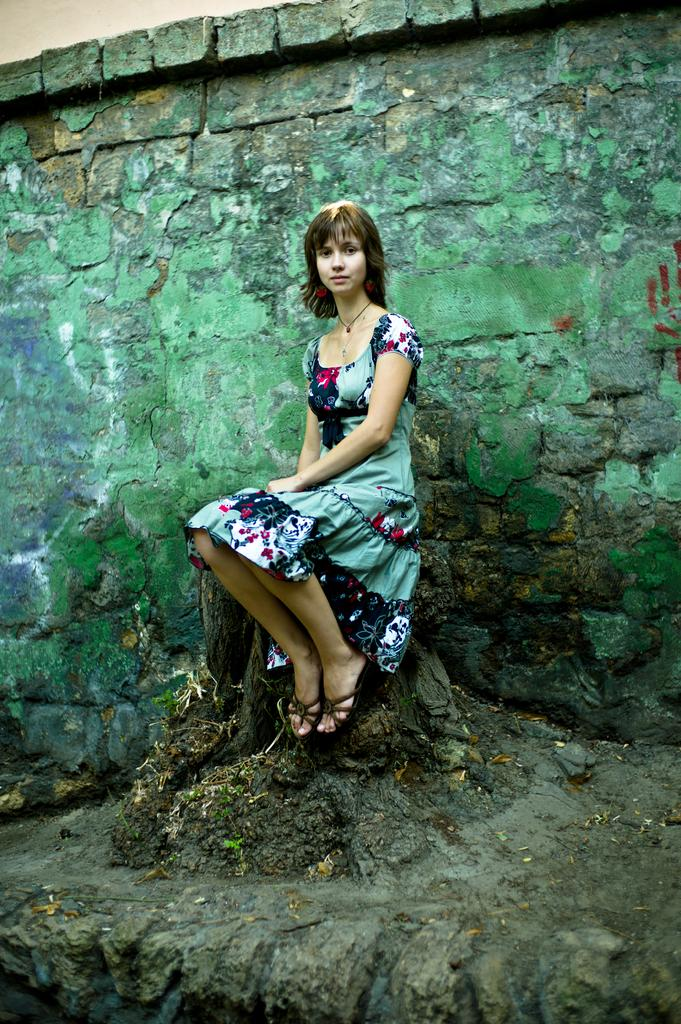Who is the main subject in the image? There is a girl in the image. What is the girl doing in the image? The girl is sitting on a tree trunk. What can be seen in the background of the image? There is a brick wall in the background of the image. What type of attraction is the girl visiting in the image? There is no indication of an attraction in the image; it simply shows a girl sitting on a tree trunk with a brick wall in the background. 